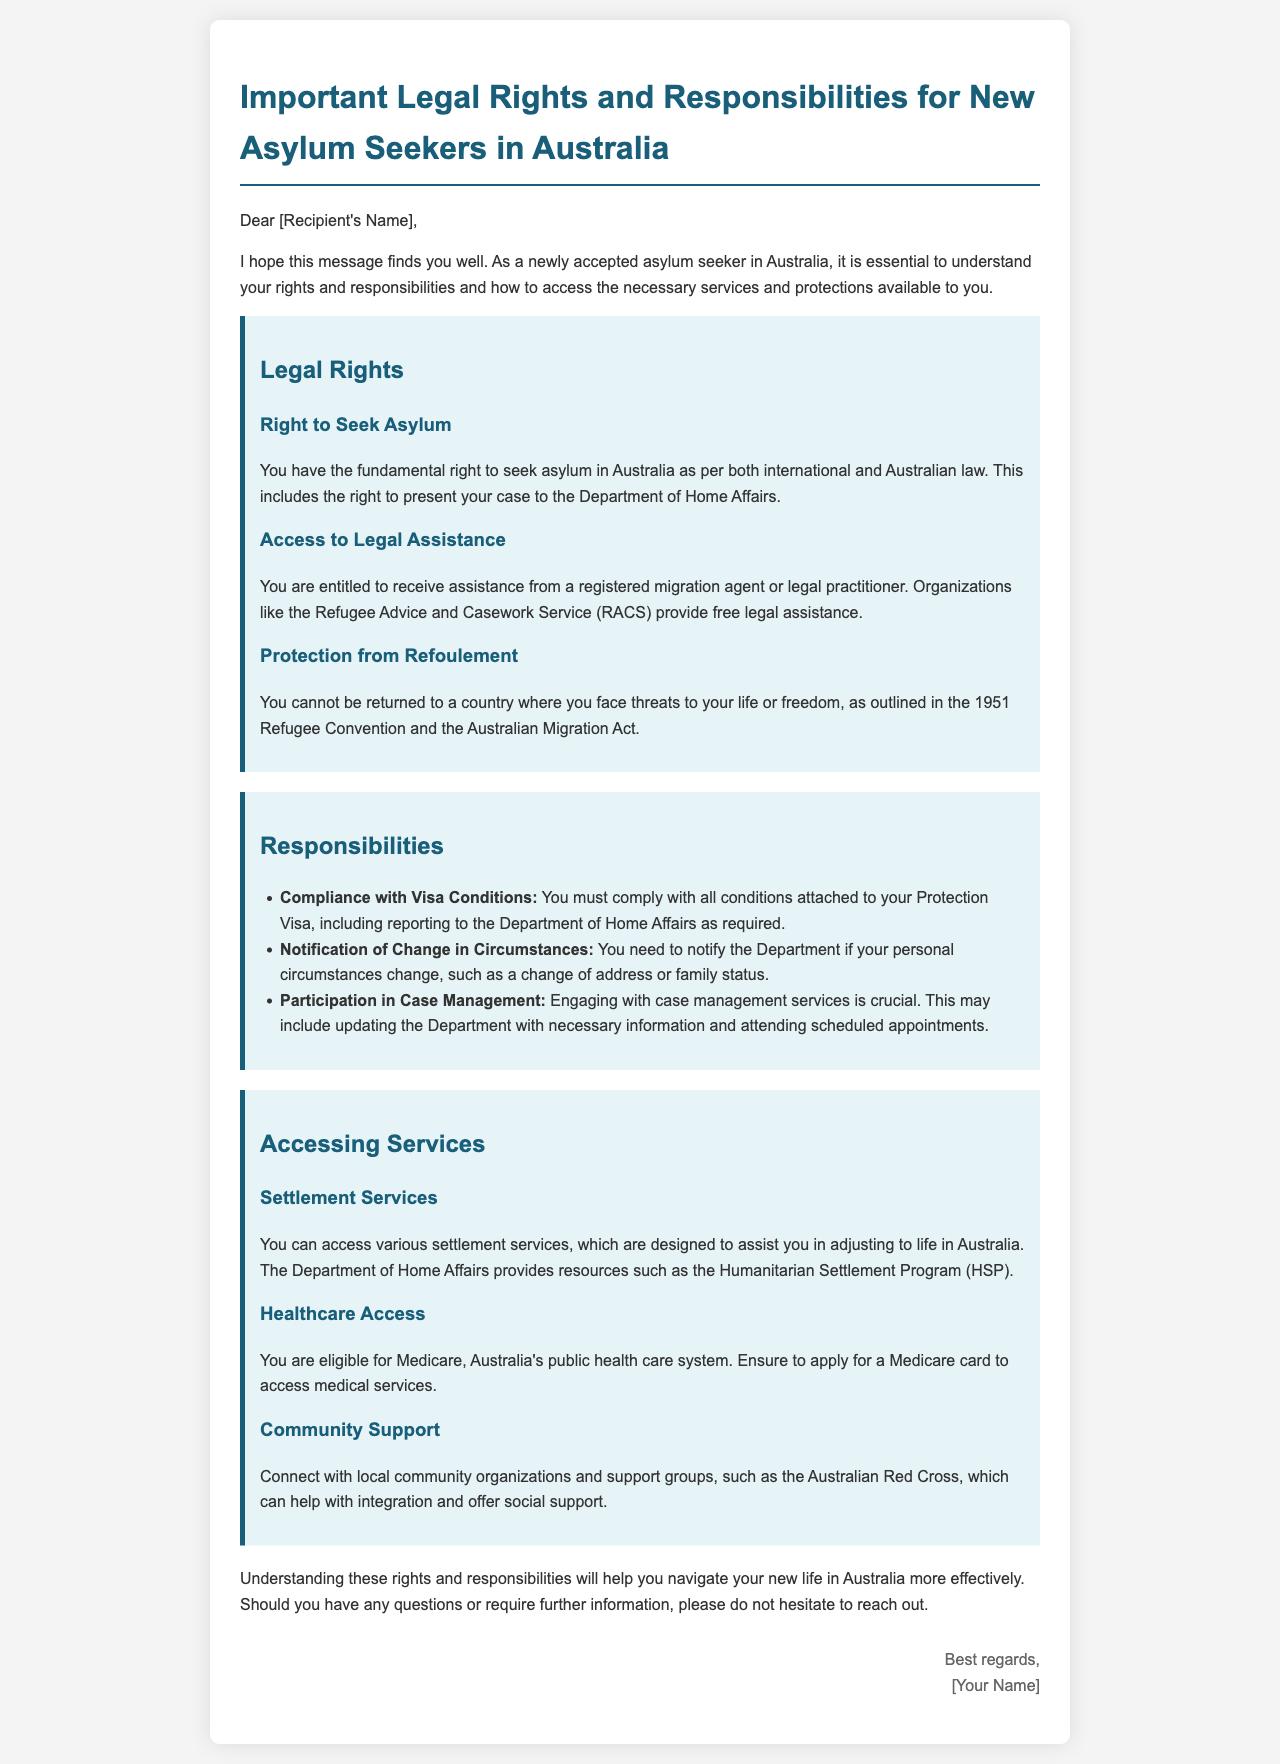what is the right to seek asylum? The right to seek asylum is fundamental according to international and Australian law, allowing you to present your case to the Department of Home Affairs.
Answer: fundamental right who can provide legal assistance? Legal assistance can be provided by a registered migration agent or legal practitioner, with free assistance available from organizations like RACS.
Answer: RACS what must you comply with as a responsibility? You must comply with all conditions attached to your Protection Visa, including reporting to the Department of Home Affairs as required.
Answer: Protection Visa conditions what should you notify the Department about? You need to notify the Department if your personal circumstances change, such as a change of address or family status.
Answer: change in circumstances what program is available for settlement services? The Humanitarian Settlement Program (HSP) is available for settlement services to assist in adjusting to life in Australia.
Answer: Humanitarian Settlement Program what healthcare system can you access? You are eligible for Medicare, which is Australia's public health care system.
Answer: Medicare which community organization can help with support? The Australian Red Cross can provide community support and help with integration.
Answer: Australian Red Cross what is the main purpose of the document? The main purpose of the document is to outline important legal rights and responsibilities for new asylum seekers in Australia.
Answer: outline legal rights and responsibilities who is the message addressed to? The message is addressed to [Recipient's Name].
Answer: [Recipient's Name] 